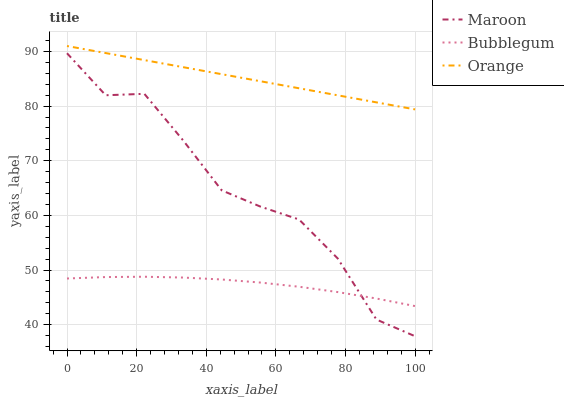Does Maroon have the minimum area under the curve?
Answer yes or no. No. Does Maroon have the maximum area under the curve?
Answer yes or no. No. Is Bubblegum the smoothest?
Answer yes or no. No. Is Bubblegum the roughest?
Answer yes or no. No. Does Bubblegum have the lowest value?
Answer yes or no. No. Does Maroon have the highest value?
Answer yes or no. No. Is Maroon less than Orange?
Answer yes or no. Yes. Is Orange greater than Maroon?
Answer yes or no. Yes. Does Maroon intersect Orange?
Answer yes or no. No. 